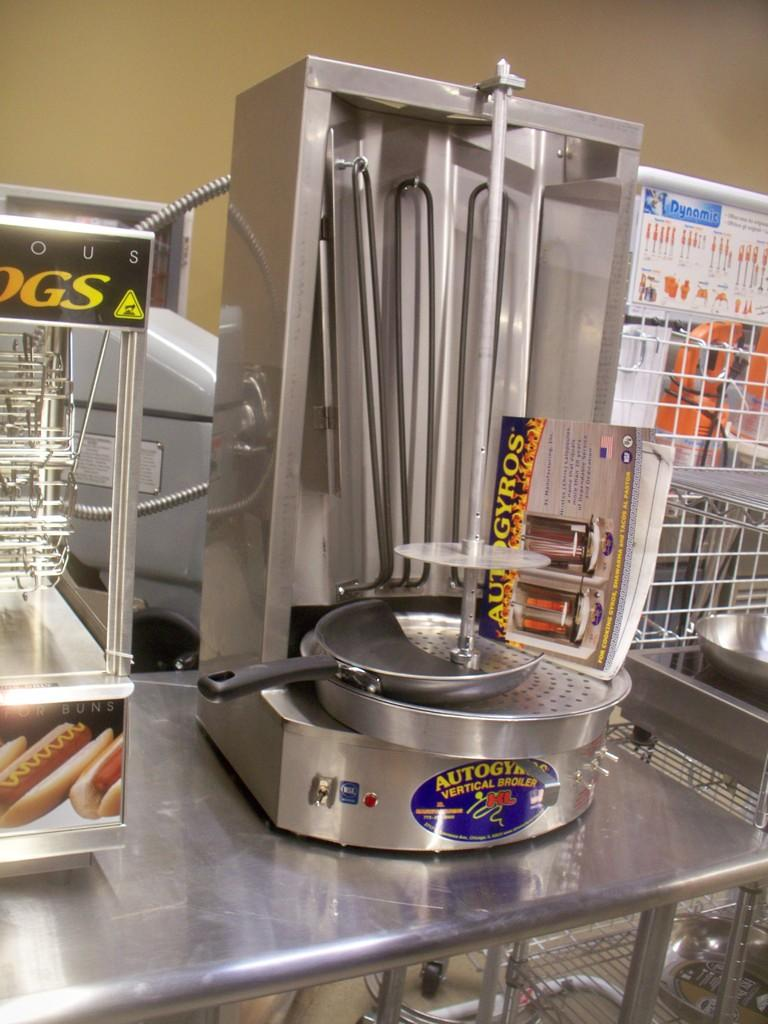<image>
Offer a succinct explanation of the picture presented. a blue sticker that hads the word dynamic at the top 